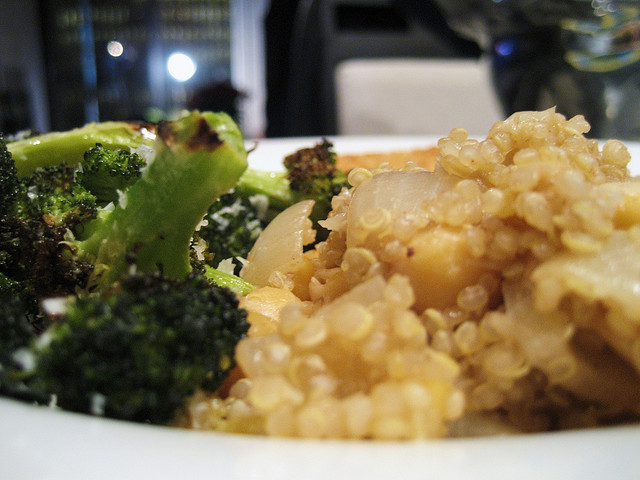<image>What type of sauce is shown? There is no sauce shown in the image. However, it can be cheese, tapioca, or soy. What is the silver object? I don't know what the silver object is. It could be a plate, refrigerator, fork, onion, quinoa, or there might not be any silver object in the image. What type of sauce is shown? I am not sure what type of sauce is shown. It can be cheese, tapioca, soy, or none. What is the silver object? There is a silver object in the image, but I don't know what it is. It can be a plate, a fork, or a pan. 